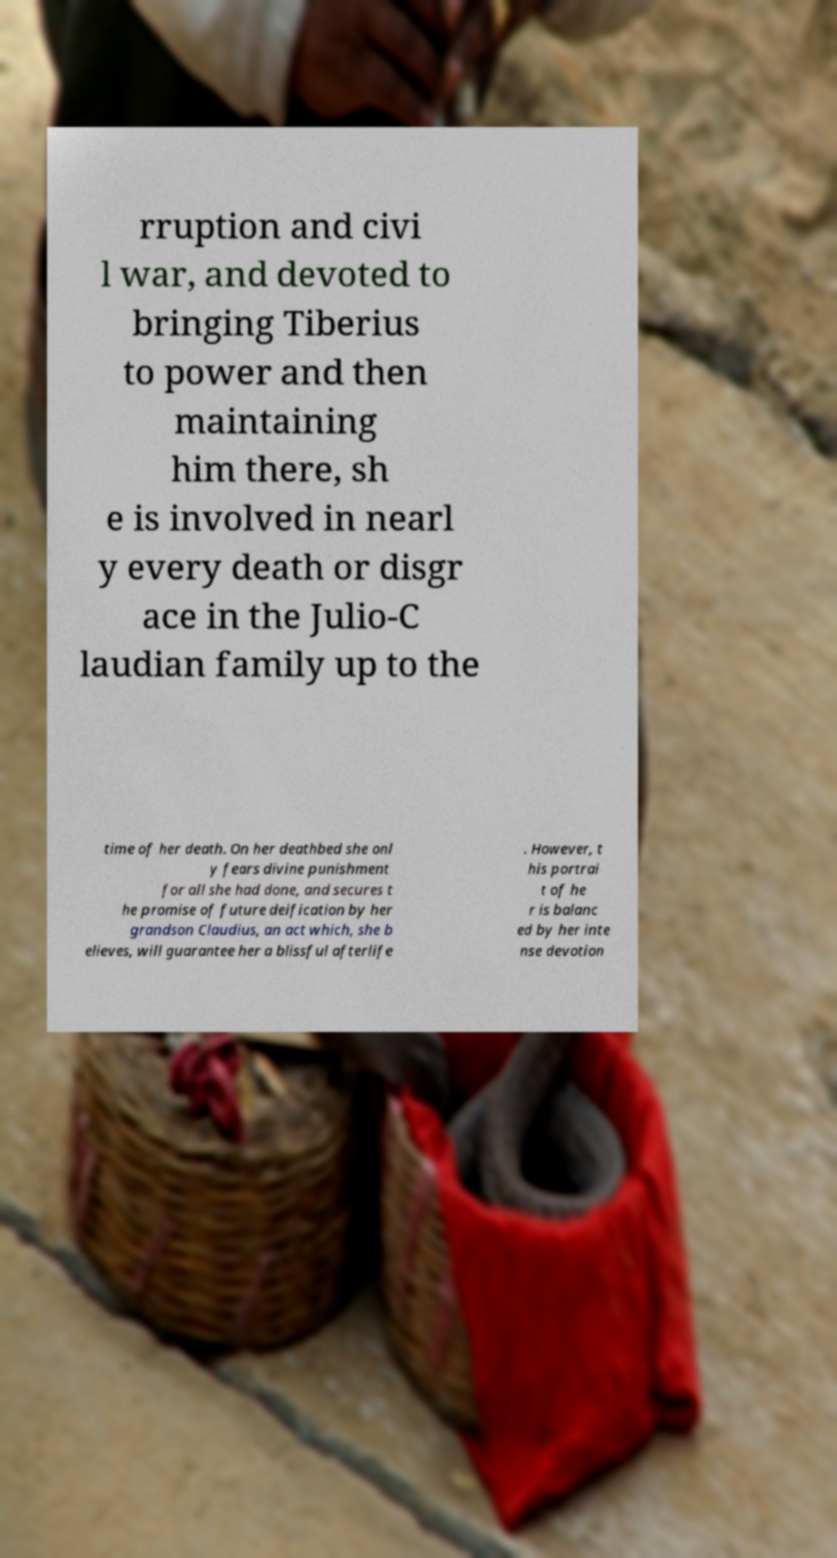Can you accurately transcribe the text from the provided image for me? rruption and civi l war, and devoted to bringing Tiberius to power and then maintaining him there, sh e is involved in nearl y every death or disgr ace in the Julio-C laudian family up to the time of her death. On her deathbed she onl y fears divine punishment for all she had done, and secures t he promise of future deification by her grandson Claudius, an act which, she b elieves, will guarantee her a blissful afterlife . However, t his portrai t of he r is balanc ed by her inte nse devotion 